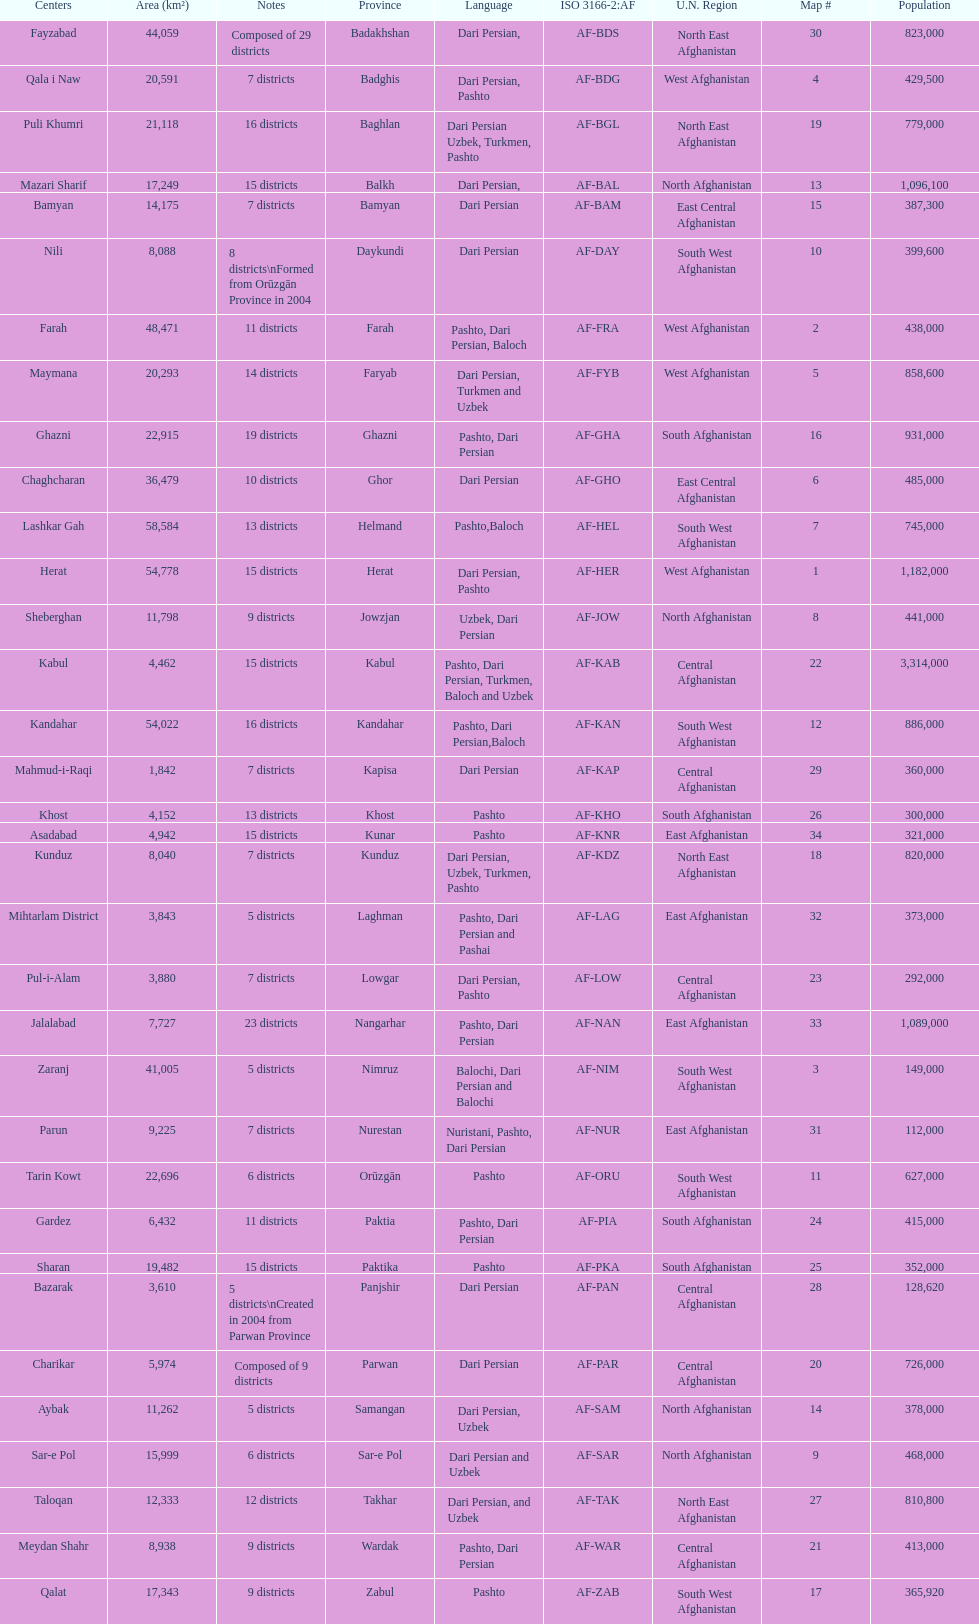Does ghor or farah have more districts? Farah. 